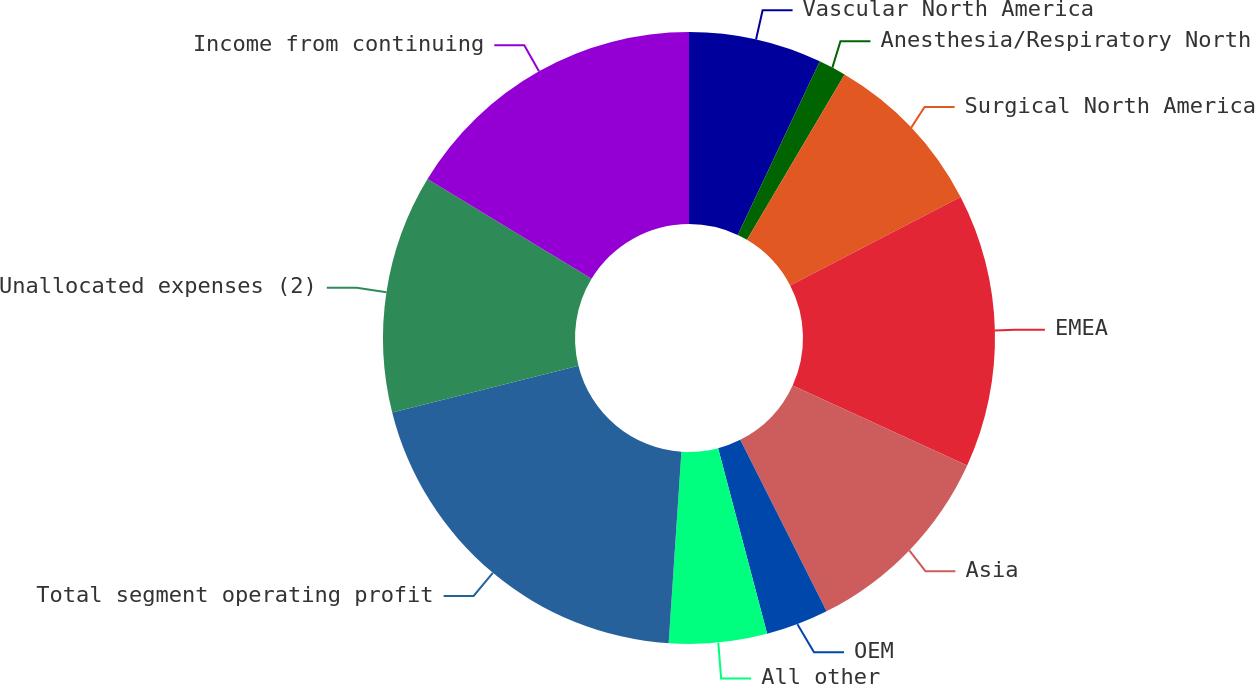<chart> <loc_0><loc_0><loc_500><loc_500><pie_chart><fcel>Vascular North America<fcel>Anesthesia/Respiratory North<fcel>Surgical North America<fcel>EMEA<fcel>Asia<fcel>OEM<fcel>All other<fcel>Total segment operating profit<fcel>Unallocated expenses (2)<fcel>Income from continuing<nl><fcel>7.03%<fcel>1.46%<fcel>8.89%<fcel>14.46%<fcel>10.74%<fcel>3.31%<fcel>5.17%<fcel>20.03%<fcel>12.6%<fcel>16.31%<nl></chart> 